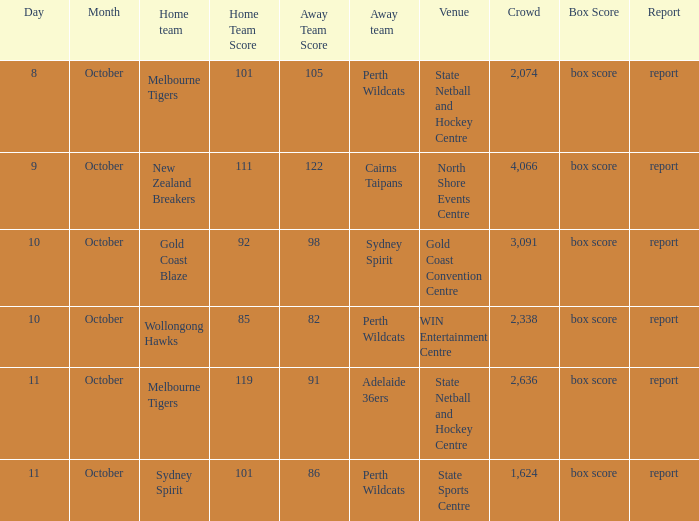What was the number of the crowd when the Wollongong Hawks were the home team? 2338.0. 